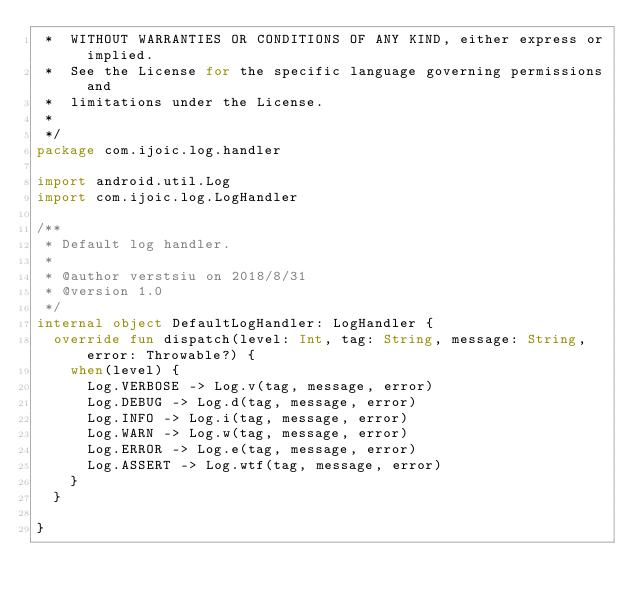<code> <loc_0><loc_0><loc_500><loc_500><_Kotlin_> *  WITHOUT WARRANTIES OR CONDITIONS OF ANY KIND, either express or implied.
 *  See the License for the specific language governing permissions and
 *  limitations under the License.
 *
 */
package com.ijoic.log.handler

import android.util.Log
import com.ijoic.log.LogHandler

/**
 * Default log handler.
 *
 * @author verstsiu on 2018/8/31
 * @version 1.0
 */
internal object DefaultLogHandler: LogHandler {
  override fun dispatch(level: Int, tag: String, message: String, error: Throwable?) {
    when(level) {
      Log.VERBOSE -> Log.v(tag, message, error)
      Log.DEBUG -> Log.d(tag, message, error)
      Log.INFO -> Log.i(tag, message, error)
      Log.WARN -> Log.w(tag, message, error)
      Log.ERROR -> Log.e(tag, message, error)
      Log.ASSERT -> Log.wtf(tag, message, error)
    }
  }

}</code> 